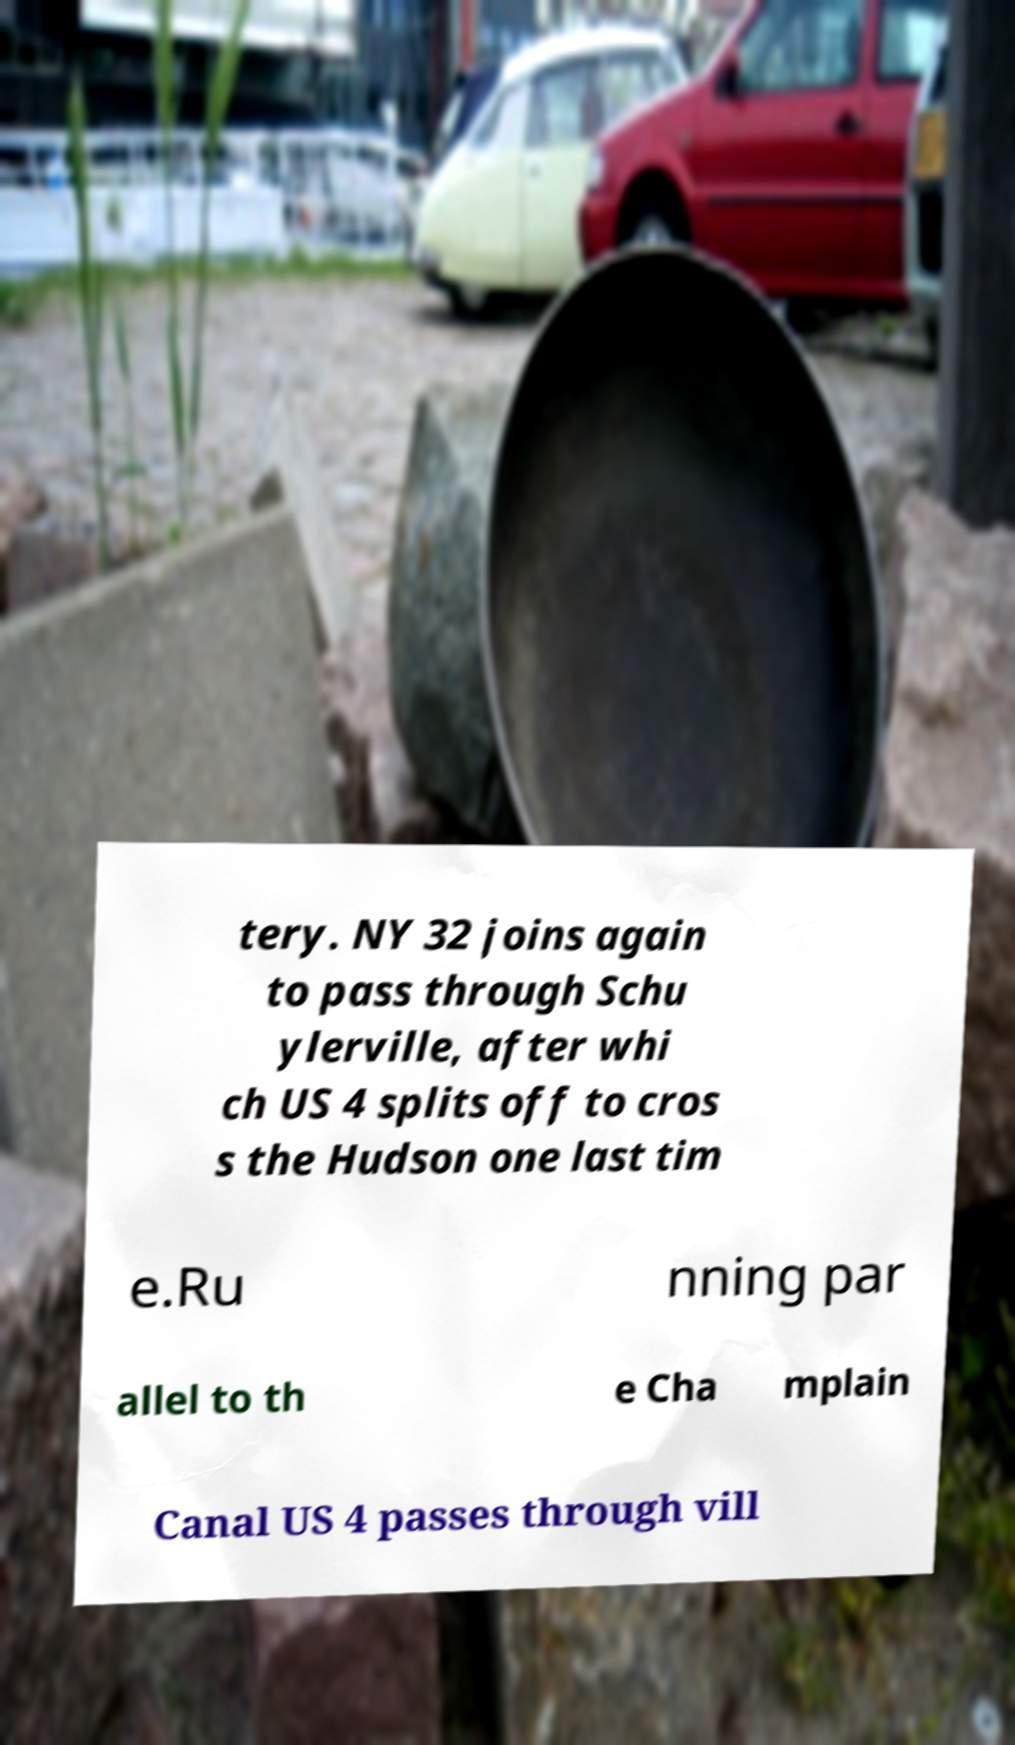Could you extract and type out the text from this image? tery. NY 32 joins again to pass through Schu ylerville, after whi ch US 4 splits off to cros s the Hudson one last tim e.Ru nning par allel to th e Cha mplain Canal US 4 passes through vill 